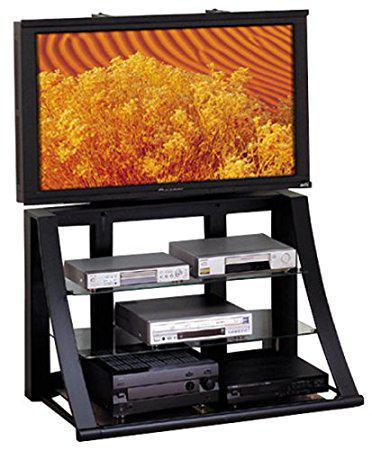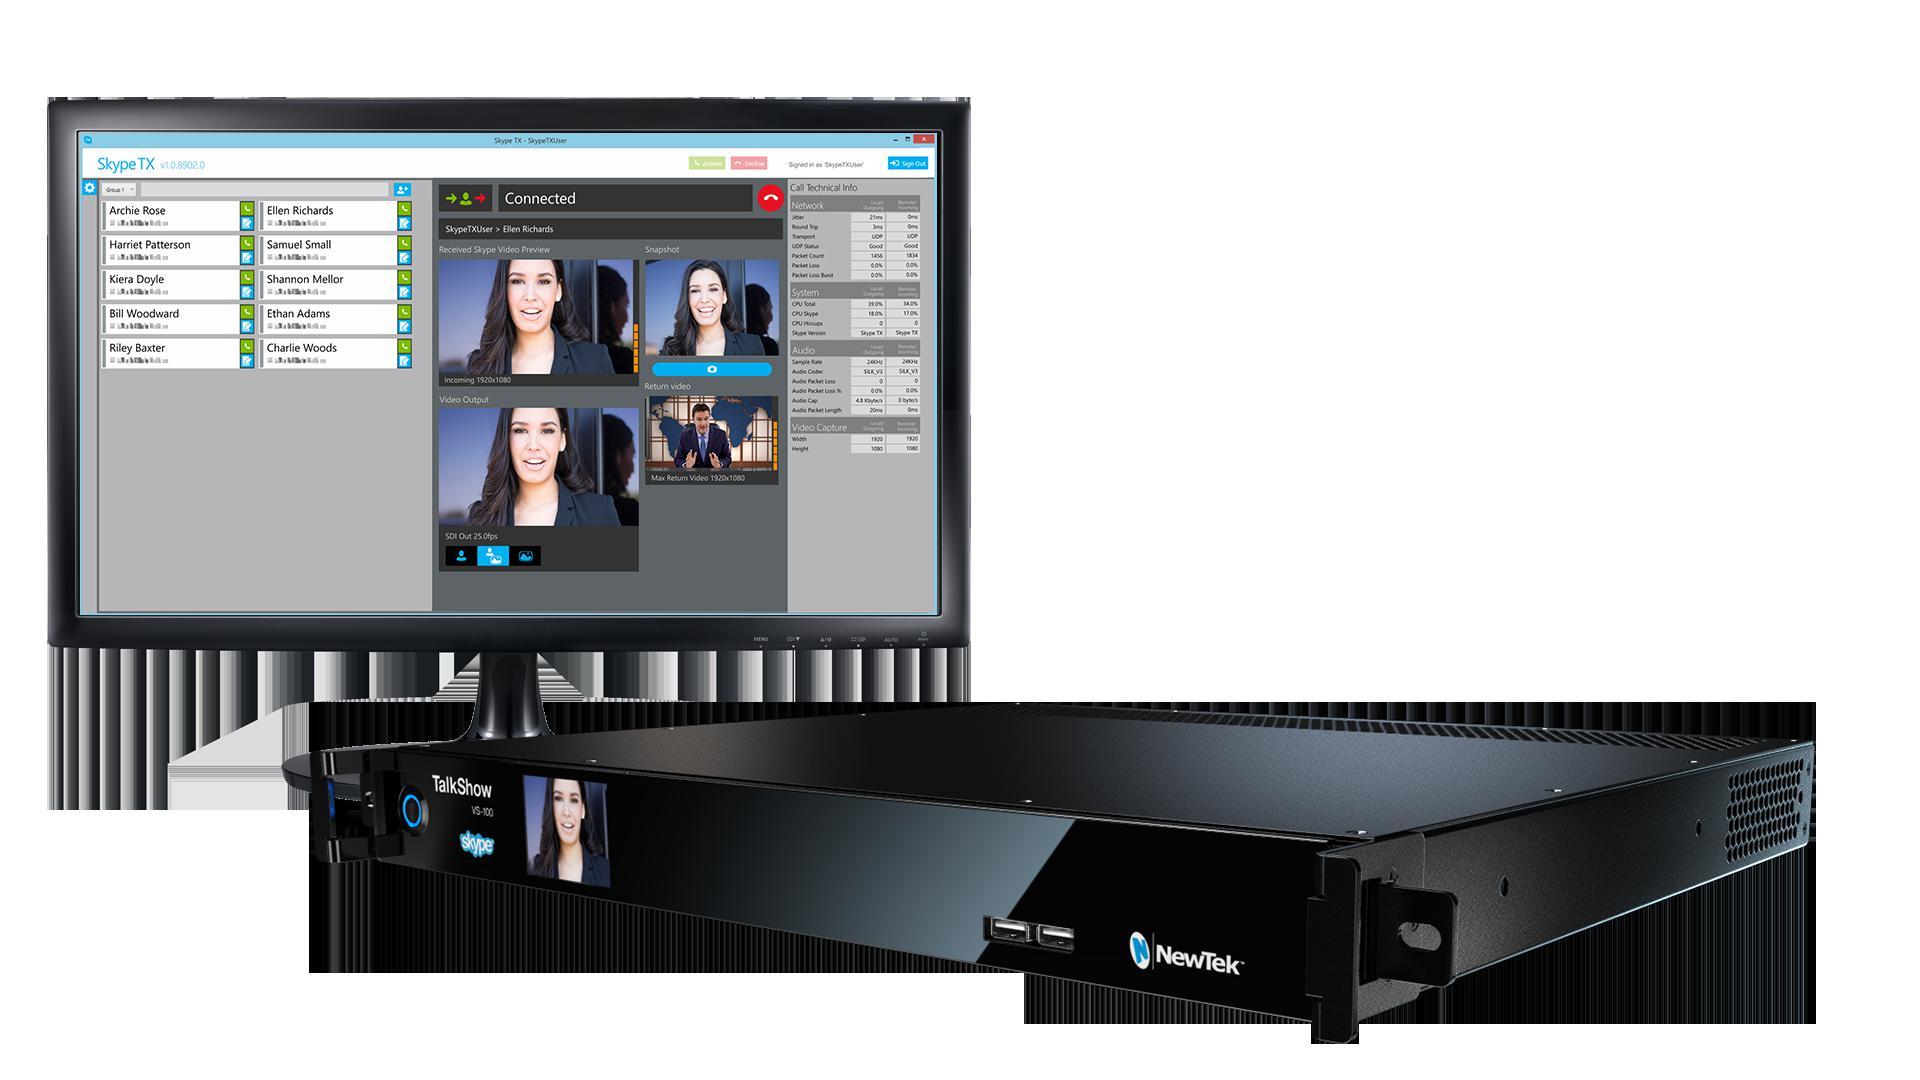The first image is the image on the left, the second image is the image on the right. For the images displayed, is the sentence "One of the images contains a VCR." factually correct? Answer yes or no. Yes. 